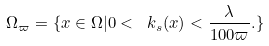<formula> <loc_0><loc_0><loc_500><loc_500>\Omega _ { \varpi } = \{ x \in \Omega | 0 < \ k _ { s } ( x ) < \frac { \lambda } { 1 0 0 \varpi } . \}</formula> 